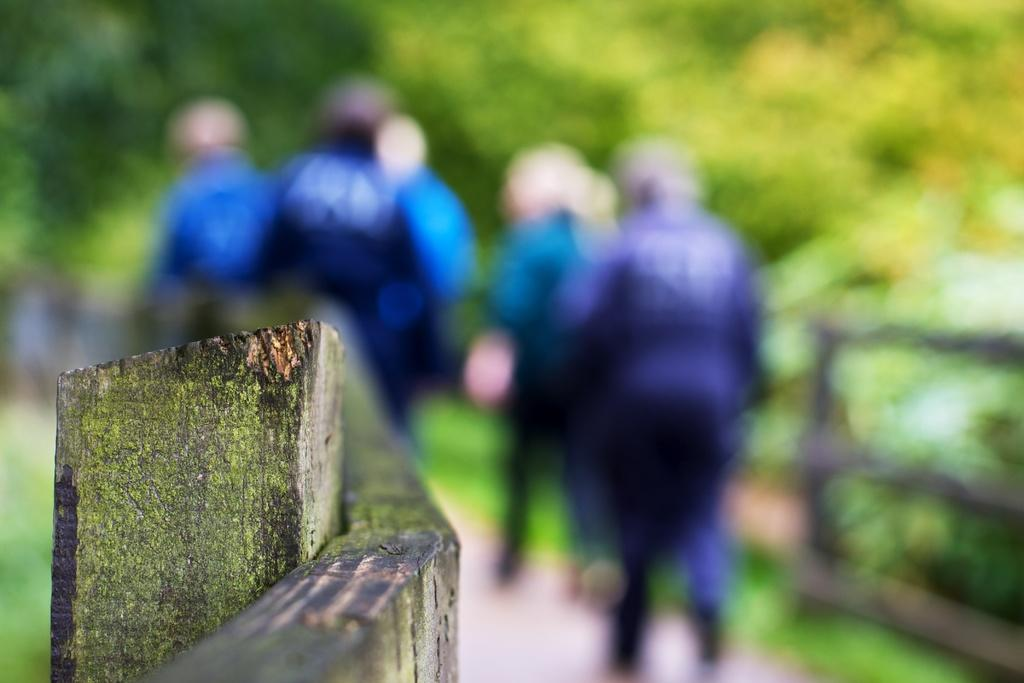What is located in the foreground of the image? There is a wooden railing in the foreground of the image. What can be seen in the background of the image? There are people visible in the background of the image, and there is also greenery. What type of cabbage is being discussed at the meeting in the image? There is no meeting or cabbage present in the image. 